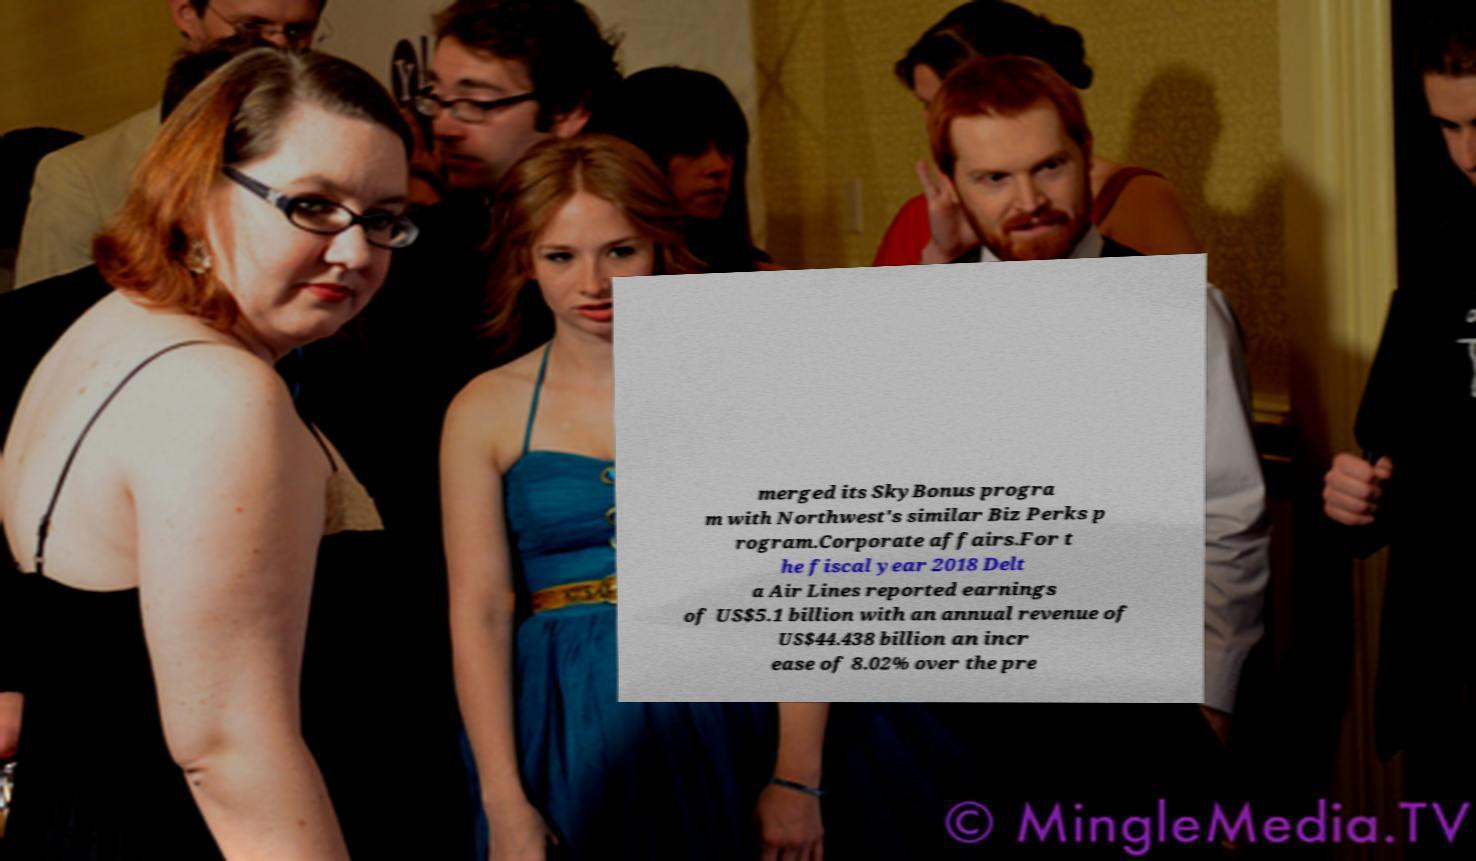Can you accurately transcribe the text from the provided image for me? merged its SkyBonus progra m with Northwest's similar Biz Perks p rogram.Corporate affairs.For t he fiscal year 2018 Delt a Air Lines reported earnings of US$5.1 billion with an annual revenue of US$44.438 billion an incr ease of 8.02% over the pre 